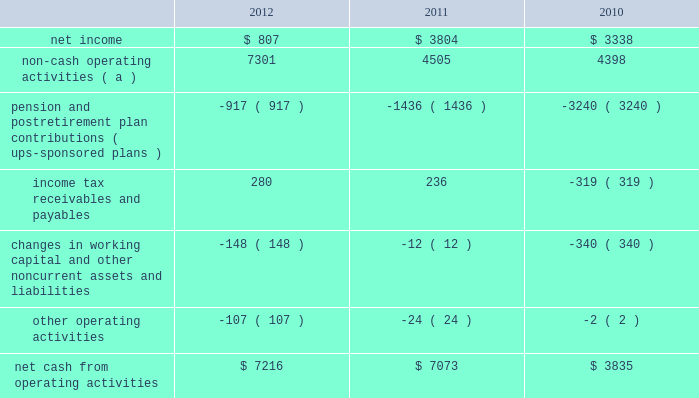United parcel service , inc .
And subsidiaries management's discussion and analysis of financial condition and results of operations liquidity and capital resources operating activities the following is a summary of the significant sources ( uses ) of cash from operating activities ( amounts in millions ) : .
( a ) represents depreciation and amortization , gains and losses on derivative and foreign exchange transactions , deferred income taxes , provisions for uncollectible accounts , pension and postretirement benefit expense , stock compensation expense , impairment charges and other non-cash items .
Cash from operating activities remained strong throughout the 2010 to 2012 time period .
Operating cash flow was favorably impacted in 2012 , compared with 2011 , by lower contributions into our defined benefit pension and postretirement benefit plans ; however , this was partially offset by changes in our working capital position , which was impacted by overall growth in the business .
The change in the cash flows for income tax receivables and payables in 2011 and 2010 was primarily related to the timing of discretionary pension contributions during 2010 , as discussed further in the following paragraph .
Except for discretionary or accelerated fundings of our plans , contributions to our company-sponsored pension plans have largely varied based on whether any minimum funding requirements are present for individual pension plans .
2022 in 2012 , we made a $ 355 million required contribution to the ups ibt pension plan .
2022 in 2011 , we made a $ 1.2 billion contribution to the ups ibt pension plan , which satisfied our 2011 contribution requirements and also approximately $ 440 million in contributions that would not have been required until after 2011 .
2022 in 2010 , we made $ 2.0 billion in discretionary contributions to our ups retirement and ups pension plans , and $ 980 million in required contributions to our ups ibt pension plan .
2022 the remaining contributions in the 2010 through 2012 period were largely due to contributions to our international pension plans and u.s .
Postretirement medical benefit plans .
As discussed further in the 201ccontractual commitments 201d section , we have minimum funding requirements in the next several years , primarily related to the ups ibt pension , ups retirement and ups pension plans .
As of december 31 , 2012 , the total of our worldwide holdings of cash and cash equivalents was $ 7.327 billion .
Approximately $ 4.211 billion of this amount was held in european subsidiaries with the intended purpose of completing the acquisition of tnt express n.v .
( see note 16 to the consolidated financial statements ) .
Excluding this portion of cash held outside the u.s .
For acquisition-related purposes , approximately 50%-60% ( 50%-60 % ) of the remaining cash and cash equivalents are held by foreign subsidiaries throughout the year .
The amount of cash held by our u.s .
And foreign subsidiaries fluctuates throughout the year due to a variety of factors , including the timing of cash receipts and disbursements in the normal course of business .
Cash provided by operating activities in the united states continues to be our primary source of funds to finance domestic operating needs , capital expenditures , share repurchases and dividend payments to shareowners .
To the extent that such amounts represent previously untaxed earnings , the cash held by foreign subsidiaries would be subject to tax if such amounts were repatriated in the form of dividends ; however , not all international cash balances would have to be repatriated in the form of a dividend if returned to the u.s .
When amounts earned by foreign subsidiaries are expected to be indefinitely reinvested , no accrual for taxes is provided. .
What was the percentage change in net cash from operating activities from 2010 to 2011? 
Computations: ((7073 - 3835) / 3835)
Answer: 0.84433. 